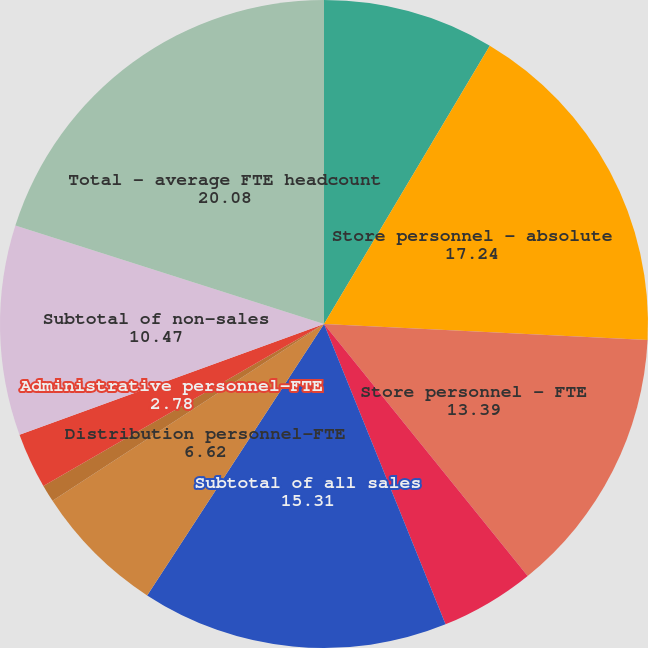Convert chart to OTSL. <chart><loc_0><loc_0><loc_500><loc_500><pie_chart><fcel>Store locations - quarter end<fcel>Store personnel - absolute<fcel>Store personnel - FTE<fcel>Non-store selling personnel -<fcel>Subtotal of all sales<fcel>Distribution personnel-FTE<fcel>Manufacturing personnel - FTE<fcel>Administrative personnel-FTE<fcel>Subtotal of non-sales<fcel>Total - average FTE headcount<nl><fcel>8.55%<fcel>17.24%<fcel>13.39%<fcel>4.7%<fcel>15.31%<fcel>6.62%<fcel>0.86%<fcel>2.78%<fcel>10.47%<fcel>20.08%<nl></chart> 